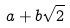<formula> <loc_0><loc_0><loc_500><loc_500>a + b \sqrt { 2 }</formula> 